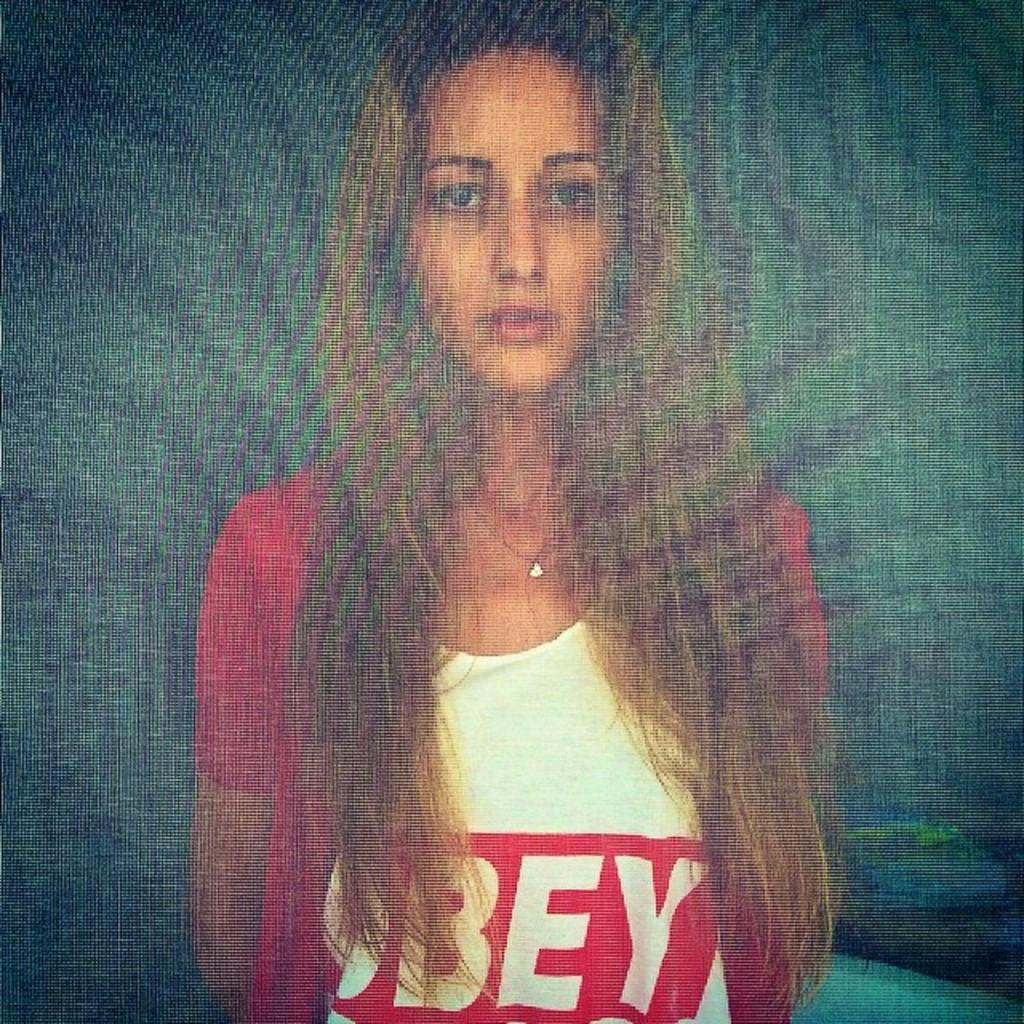Please provide a concise description of this image. In this picture we can see a blur image, on which we can see a woman. 